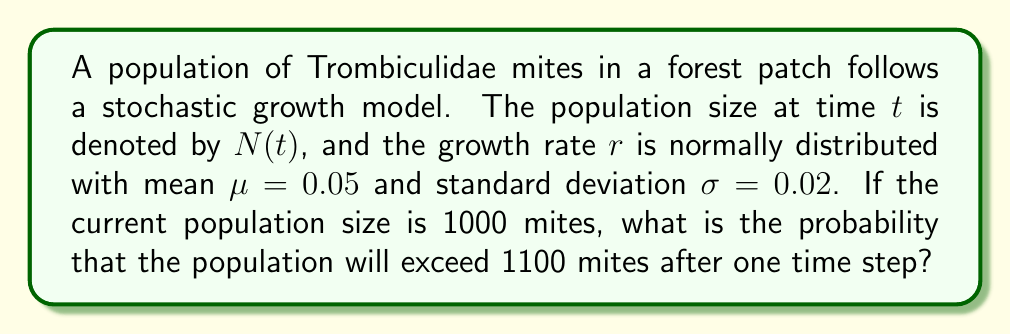Can you solve this math problem? Let's approach this step-by-step:

1) In a stochastic growth model, the population size at the next time step is given by:

   $$N(t+1) = N(t) \cdot e^r$$

   where $r$ is the growth rate.

2) We're given that $r \sim N(\mu, \sigma^2)$ where $\mu = 0.05$ and $\sigma = 0.02$.

3) We want to find $P(N(t+1) > 1100)$ given $N(t) = 1000$.

4) We can rewrite this as:

   $$P(1000 \cdot e^r > 1100)$$

5) Taking the natural log of both sides:

   $$P(r > \ln(1.1)) = P(r > 0.0953)$$

6) We can standardize this to a standard normal distribution:

   $$P\left(\frac{r - \mu}{\sigma} > \frac{0.0953 - 0.05}{0.02}\right) = P(Z > 2.265)$$

7) Using a standard normal table or calculator, we can find:

   $$P(Z > 2.265) = 1 - P(Z < 2.265) = 1 - 0.9882 = 0.0118$$

Thus, the probability that the population will exceed 1100 mites after one time step is approximately 0.0118 or 1.18%.
Answer: 0.0118 